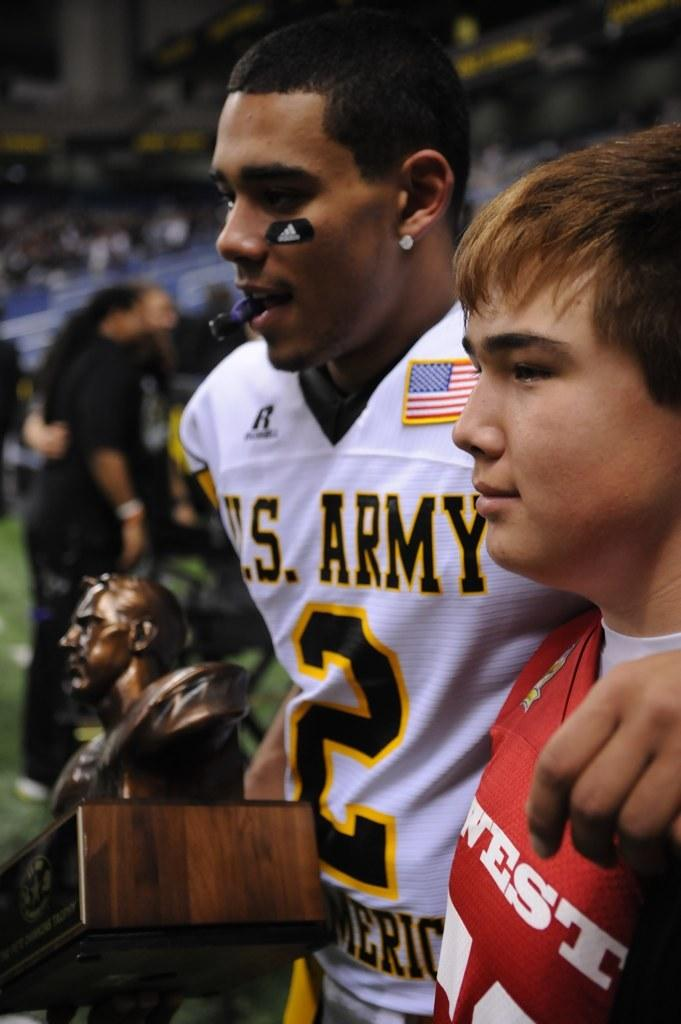<image>
Create a compact narrative representing the image presented. A man in a us army jersey holds a trophy while his arms around a young man wearing a red jersey 